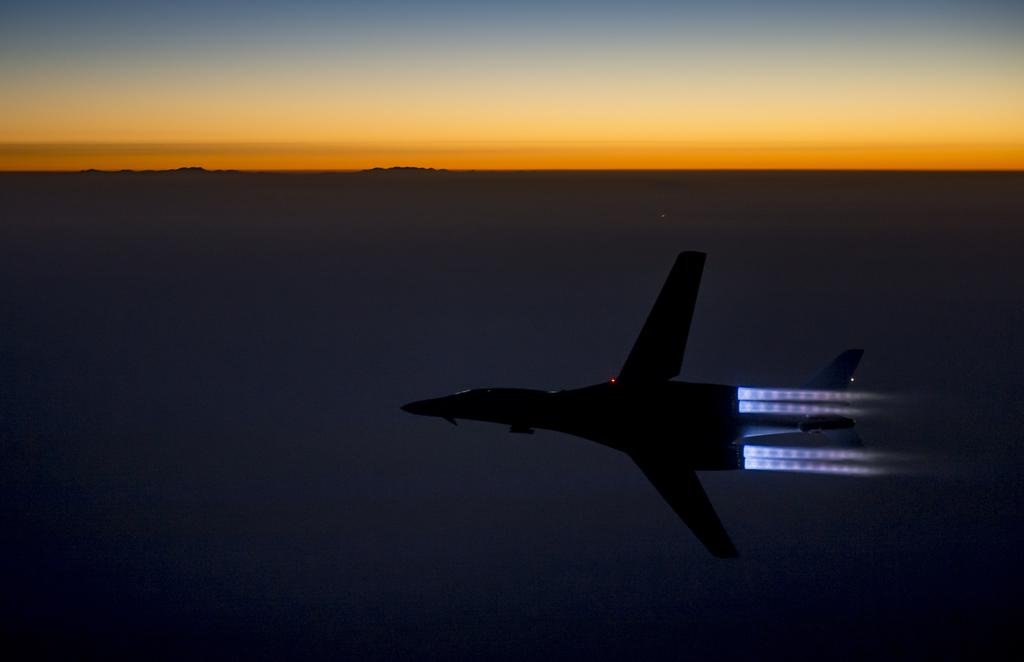What is the main subject of the image? The main subject of the image is a jet plane. Can you describe the location of the jet plane in the image? The jet plane is in the air. What type of agreement can be seen between the birds in the image? There are no birds present in the image, so there is no agreement to observe. 